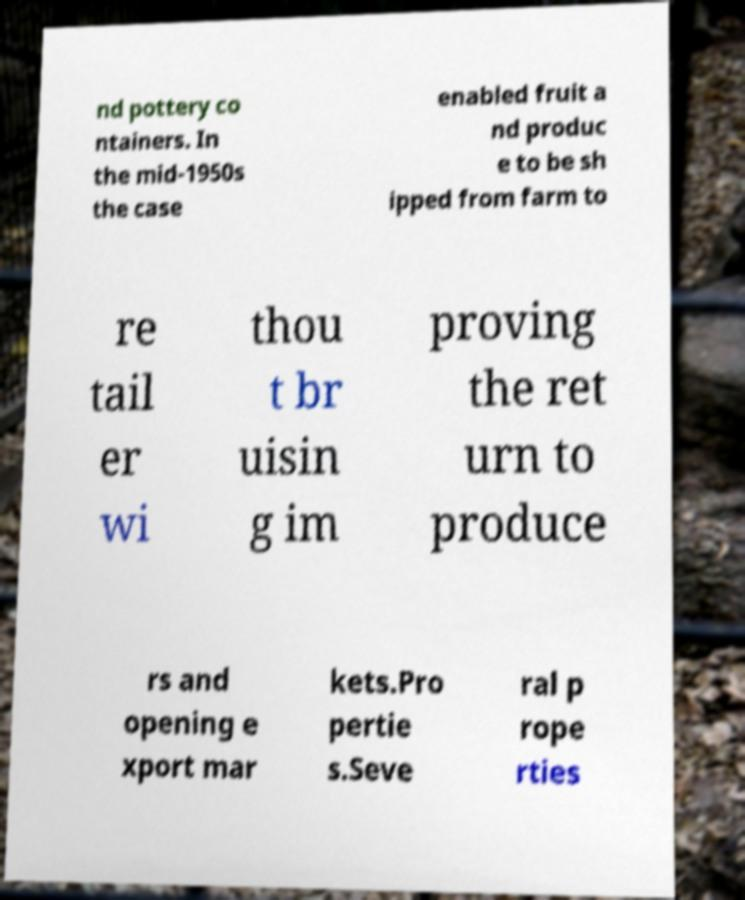Please identify and transcribe the text found in this image. nd pottery co ntainers. In the mid-1950s the case enabled fruit a nd produc e to be sh ipped from farm to re tail er wi thou t br uisin g im proving the ret urn to produce rs and opening e xport mar kets.Pro pertie s.Seve ral p rope rties 